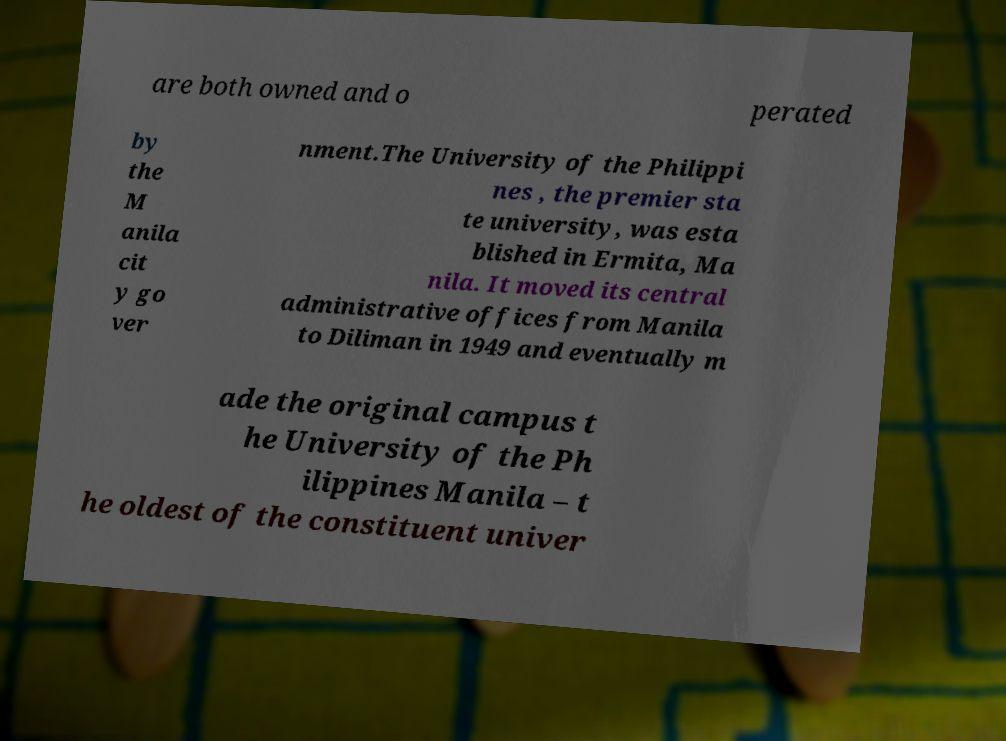I need the written content from this picture converted into text. Can you do that? are both owned and o perated by the M anila cit y go ver nment.The University of the Philippi nes , the premier sta te university, was esta blished in Ermita, Ma nila. It moved its central administrative offices from Manila to Diliman in 1949 and eventually m ade the original campus t he University of the Ph ilippines Manila – t he oldest of the constituent univer 